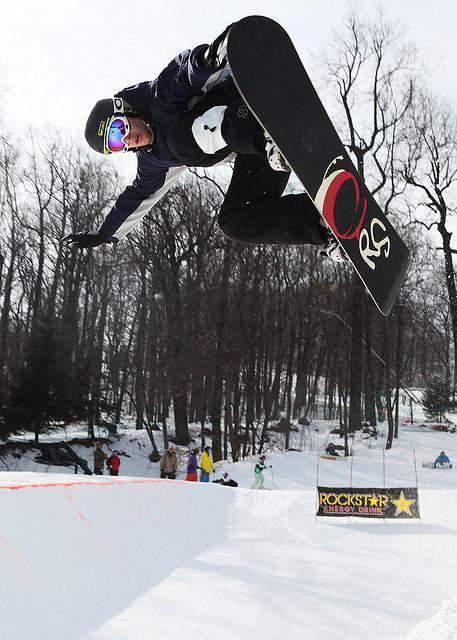How many flavors available in Rock star energy drink?
Pick the correct solution from the four options below to address the question.
Options: Ten, 15, 20, 25. 20. 